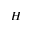Convert formula to latex. <formula><loc_0><loc_0><loc_500><loc_500>H</formula> 